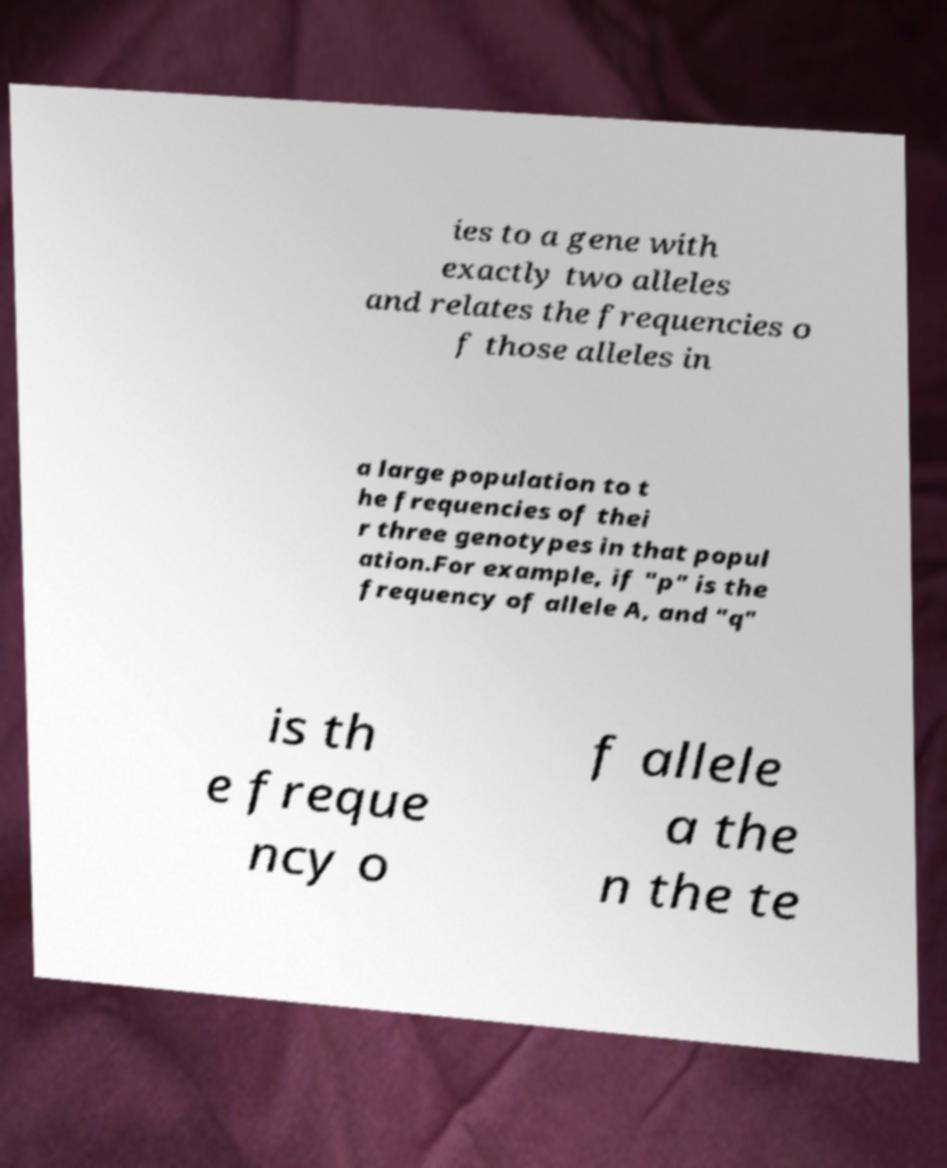Could you extract and type out the text from this image? ies to a gene with exactly two alleles and relates the frequencies o f those alleles in a large population to t he frequencies of thei r three genotypes in that popul ation.For example, if "p" is the frequency of allele A, and "q" is th e freque ncy o f allele a the n the te 